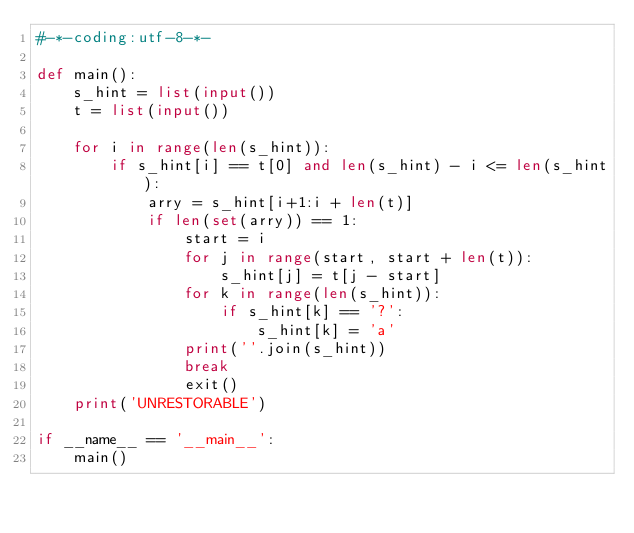Convert code to text. <code><loc_0><loc_0><loc_500><loc_500><_Python_>#-*-coding:utf-8-*-

def main():
    s_hint = list(input())
    t = list(input())

    for i in range(len(s_hint)):
        if s_hint[i] == t[0] and len(s_hint) - i <= len(s_hint):
            arry = s_hint[i+1:i + len(t)]
            if len(set(arry)) == 1:
                start = i
                for j in range(start, start + len(t)):
                    s_hint[j] = t[j - start]
                for k in range(len(s_hint)):
                    if s_hint[k] == '?':
                        s_hint[k] = 'a'
                print(''.join(s_hint))
                break
                exit()
    print('UNRESTORABLE')
                
if __name__ == '__main__':
    main()</code> 